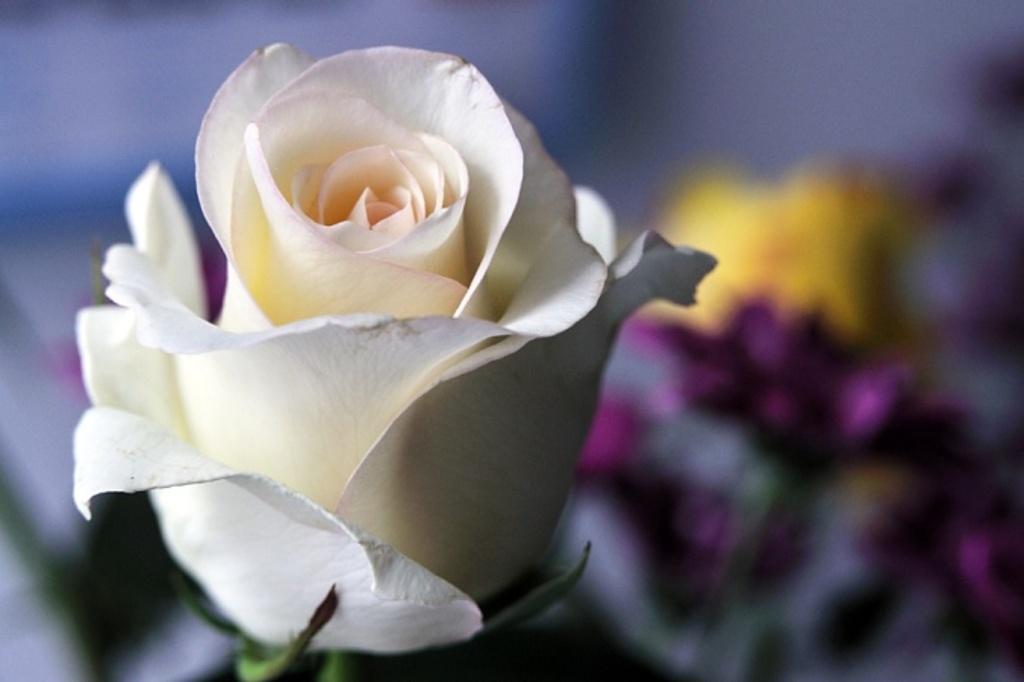Can you describe this image briefly? In this image I can see the white color flower and the background is blurred. 